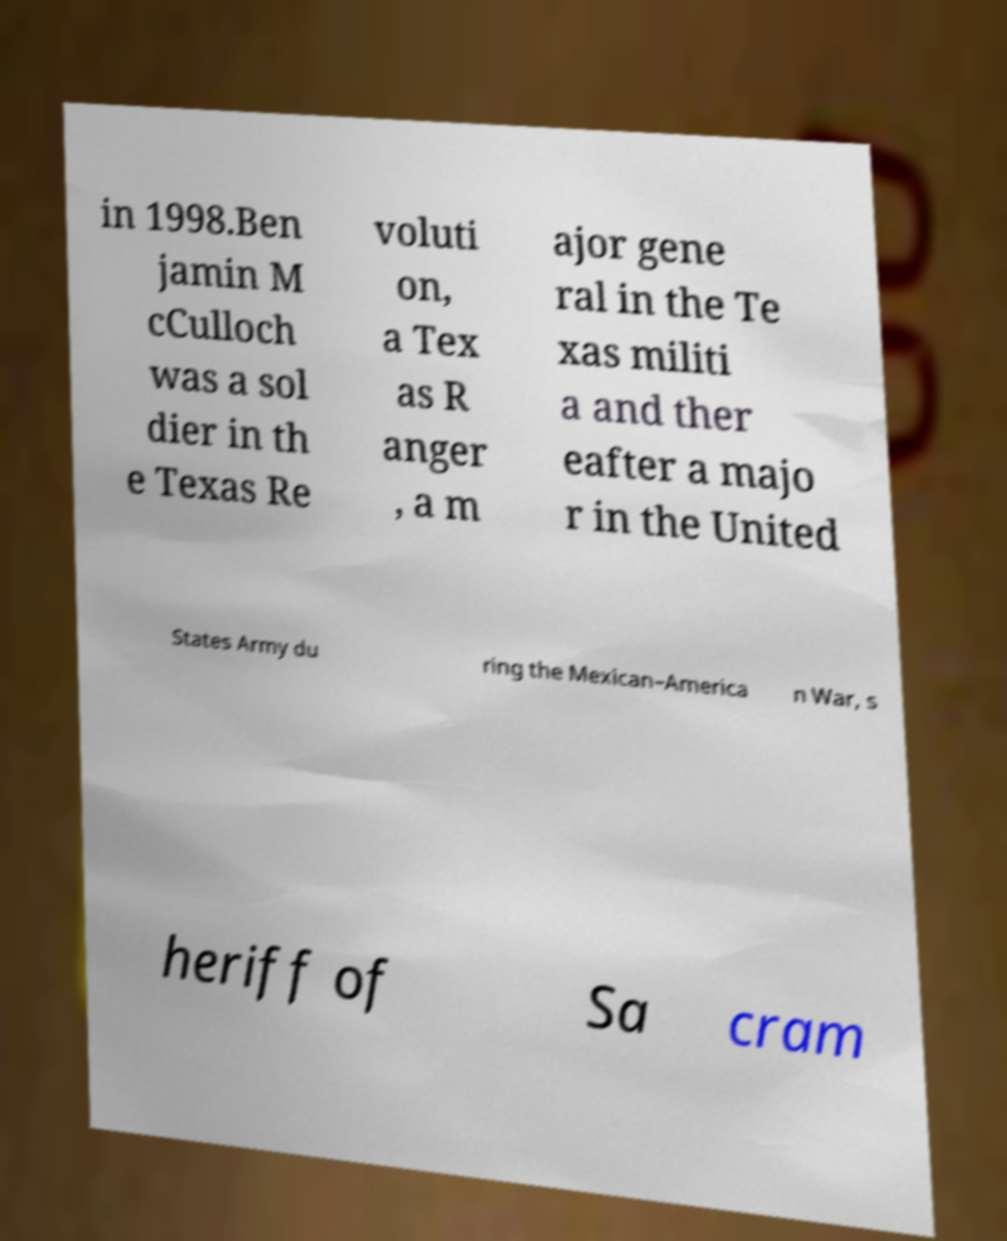There's text embedded in this image that I need extracted. Can you transcribe it verbatim? in 1998.Ben jamin M cCulloch was a sol dier in th e Texas Re voluti on, a Tex as R anger , a m ajor gene ral in the Te xas militi a and ther eafter a majo r in the United States Army du ring the Mexican–America n War, s heriff of Sa cram 